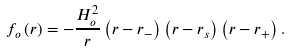Convert formula to latex. <formula><loc_0><loc_0><loc_500><loc_500>f _ { o } \left ( r \right ) = - \frac { H _ { o } ^ { 2 } } { r } \left ( r - r _ { - } \right ) \left ( r - r _ { s } \right ) \left ( r - r _ { + } \right ) .</formula> 